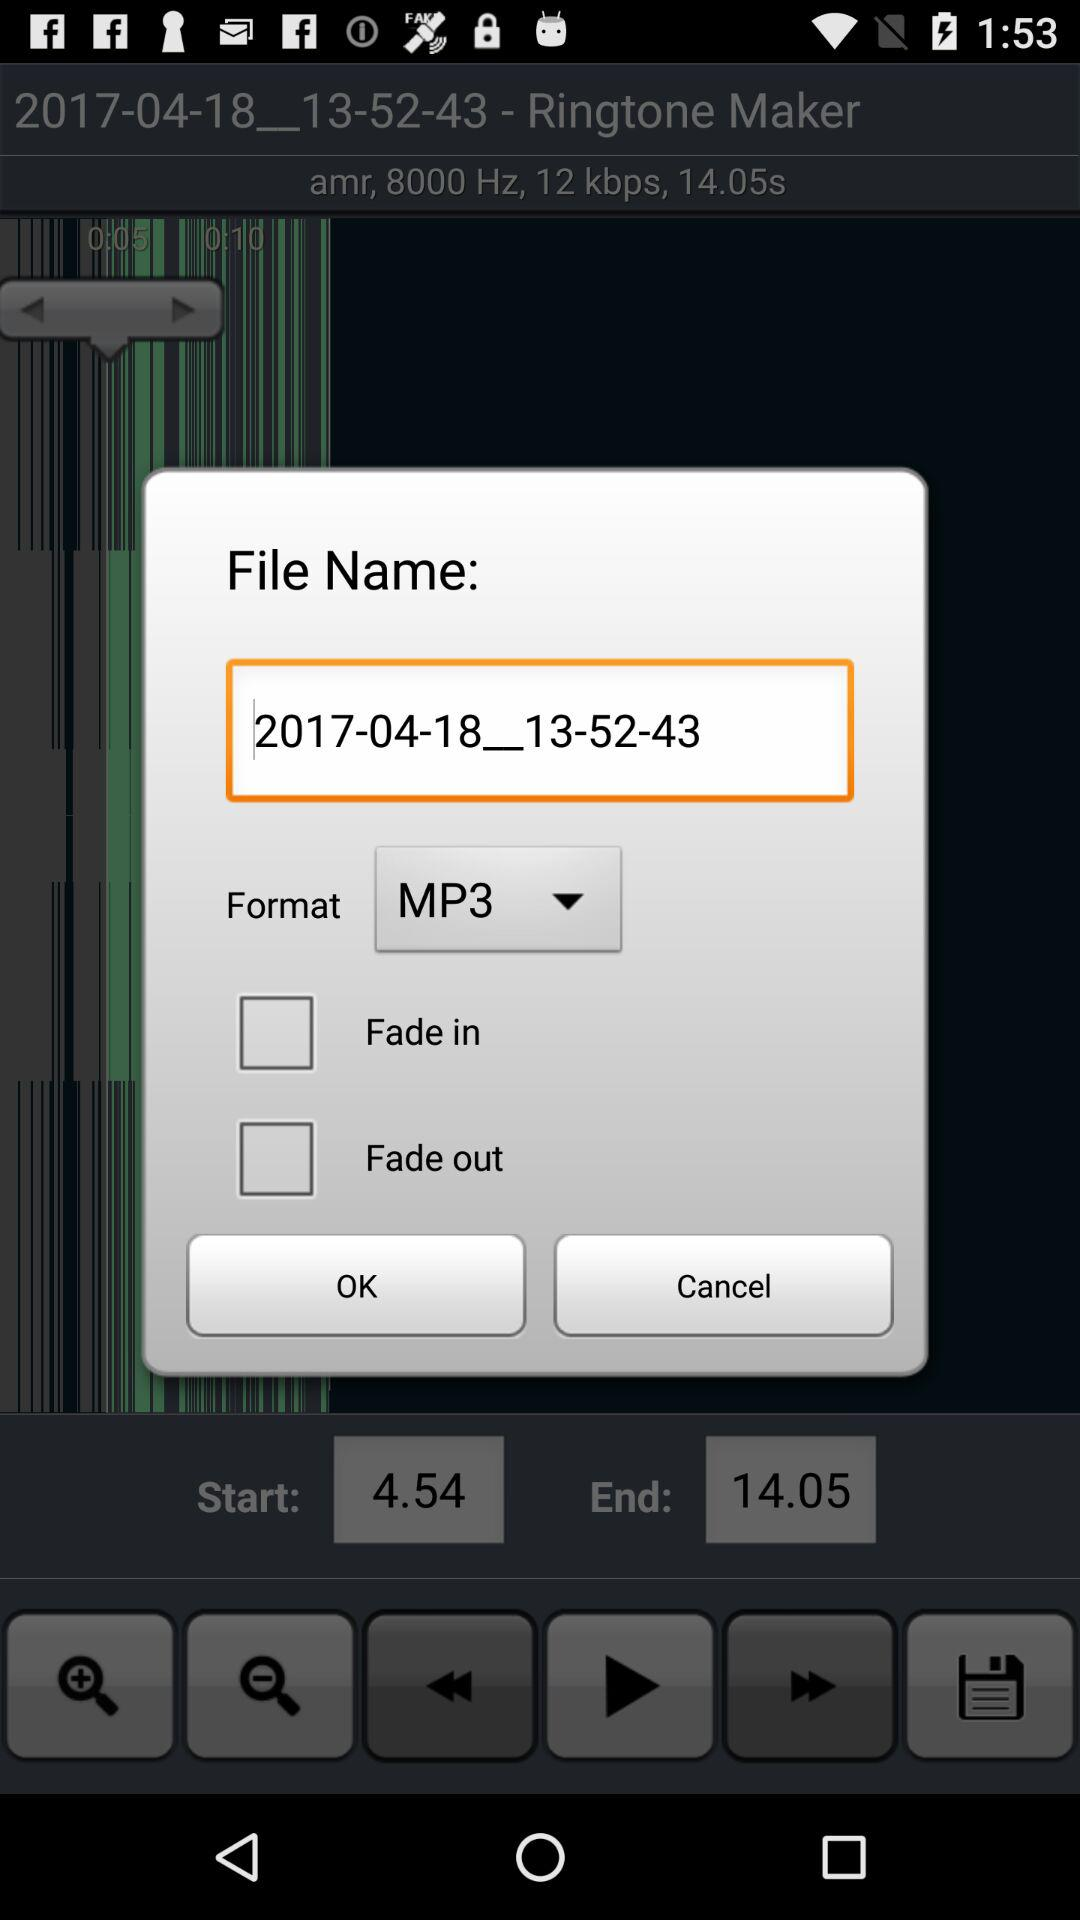What is the format of the file? The format is mp3. 